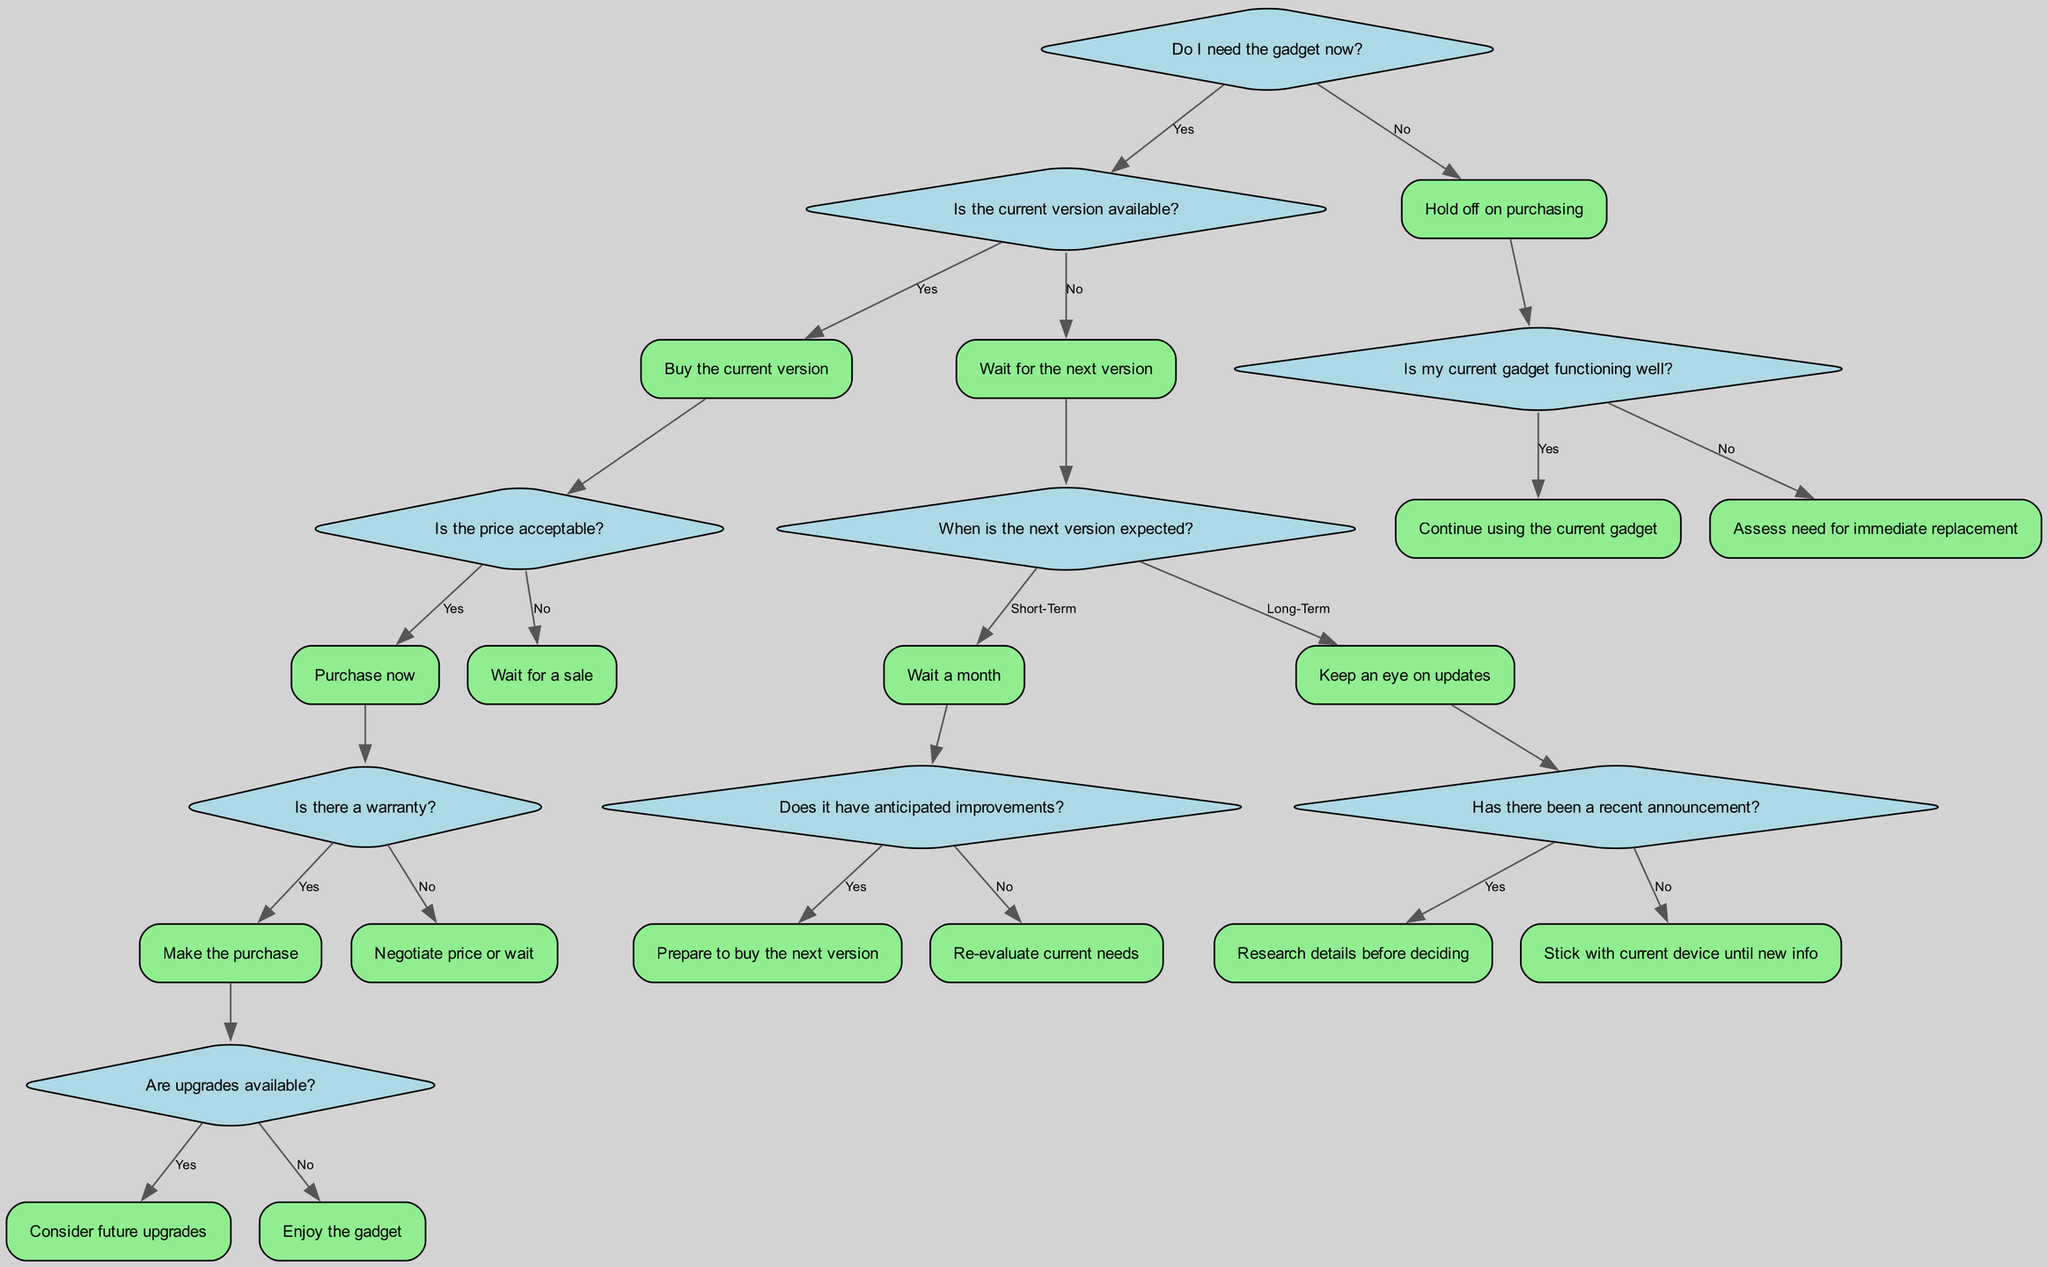Do I need the gadget now? This is the root question of the decision tree, which determines the flow of subsequent decisions based on whether the need is immediate or not.
Answer: Yes What is the action if the current version is available and the price is acceptable? If the current version is available, and the price is deemed acceptable, the decision tree specifies that the action is to purchase now.
Answer: Purchase now How many choices are available after answering "Is the price acceptable?" After this question, there are three choices: "Make the purchase," "Negotiate price or wait," and "Wait for a sale." Counting these provides the total number of choices.
Answer: Three What action is taken if my current gadget is functioning well? If the current gadget is functioning well, the action is to continue using the current gadget, which is the decision outlined at that branch of the tree.
Answer: Continue using the current gadget What should I do if the next version is expected in the long term and there hasn't been a recent announcement? In this scenario, the decision tree advises to stick with the current device until new information is available, as there is no new update to inform decisions.
Answer: Stick with current device until new info What is the outcome if I wait for the next version and the anticipated improvements are present? If improvements are anticipated for the next version, after waiting a month, the recommendation is to prepare to buy the next version, indicating a clear action based on the predictions.
Answer: Prepare to buy the next version Is there an action provided for “No” in response to "Is my current gadget functioning well?" Yes, if the current gadget is not functioning well, the action to be taken is to assess the need for immediate replacement.
Answer: Assess need for immediate replacement What happens after "Wait for a sale" if the current version is available? If the current version is available and the price is not acceptable, the next step is to wait for a sale, which is the next action specified in that branch of the decision tree.
Answer: Wait for a sale 